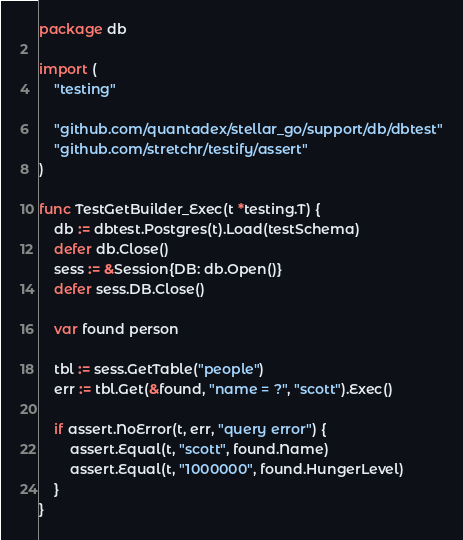Convert code to text. <code><loc_0><loc_0><loc_500><loc_500><_Go_>package db

import (
	"testing"

	"github.com/quantadex/stellar_go/support/db/dbtest"
	"github.com/stretchr/testify/assert"
)

func TestGetBuilder_Exec(t *testing.T) {
	db := dbtest.Postgres(t).Load(testSchema)
	defer db.Close()
	sess := &Session{DB: db.Open()}
	defer sess.DB.Close()

	var found person

	tbl := sess.GetTable("people")
	err := tbl.Get(&found, "name = ?", "scott").Exec()

	if assert.NoError(t, err, "query error") {
		assert.Equal(t, "scott", found.Name)
		assert.Equal(t, "1000000", found.HungerLevel)
	}
}
</code> 